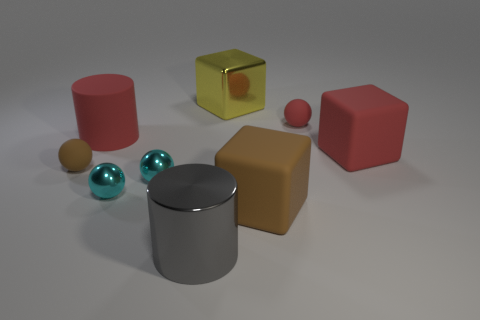Subtract all small brown matte spheres. How many spheres are left? 3 Subtract all purple cylinders. How many cyan balls are left? 2 Subtract 3 spheres. How many spheres are left? 1 Subtract all gray cylinders. How many cylinders are left? 1 Subtract 0 cyan cubes. How many objects are left? 9 Subtract all balls. How many objects are left? 5 Subtract all yellow spheres. Subtract all blue blocks. How many spheres are left? 4 Subtract all red cylinders. Subtract all large gray objects. How many objects are left? 7 Add 2 big rubber blocks. How many big rubber blocks are left? 4 Add 1 tiny red rubber objects. How many tiny red rubber objects exist? 2 